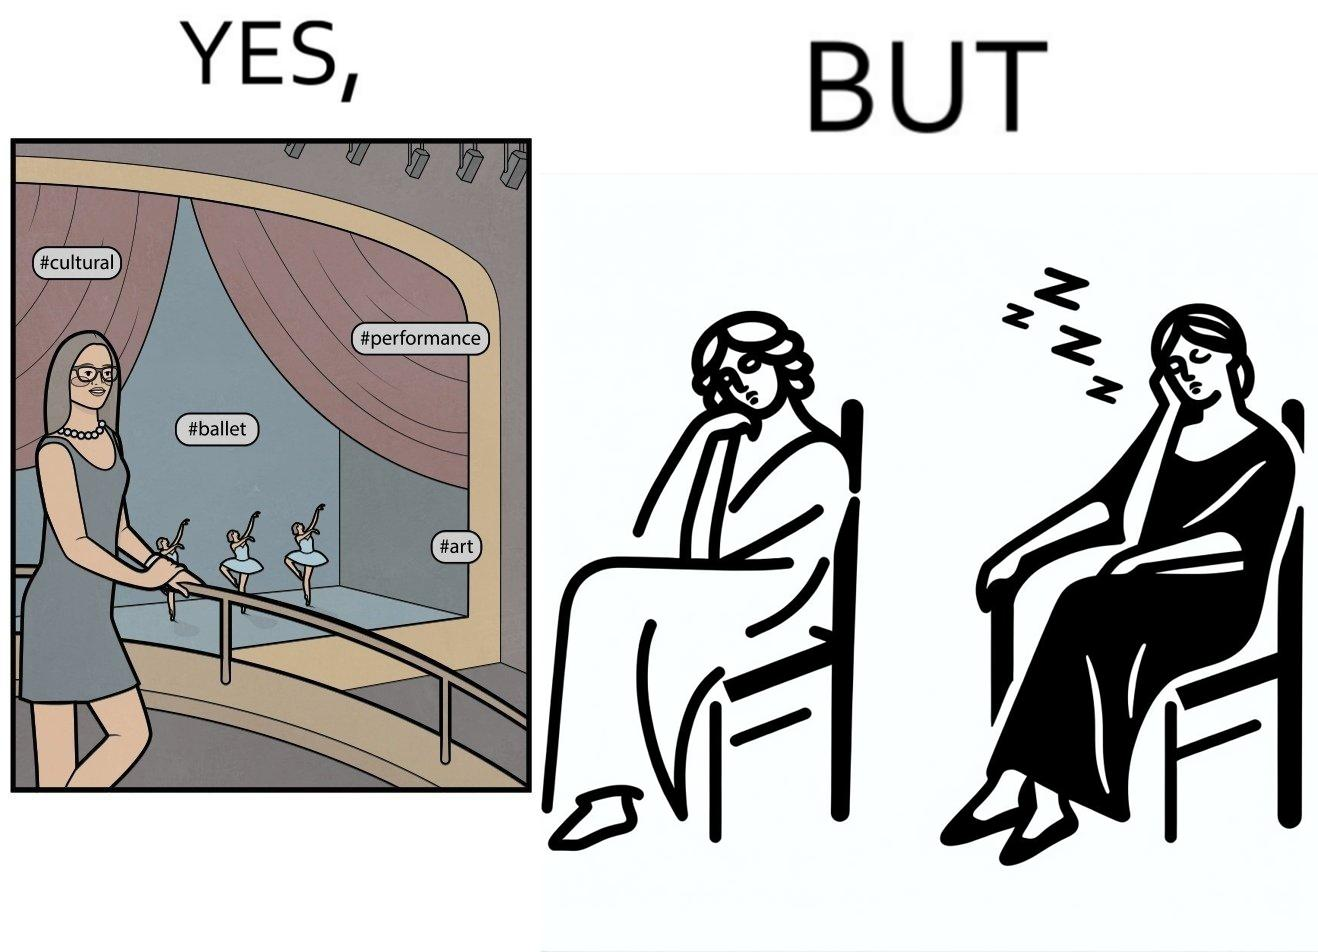Does this image contain satire or humor? Yes, this image is satirical. 